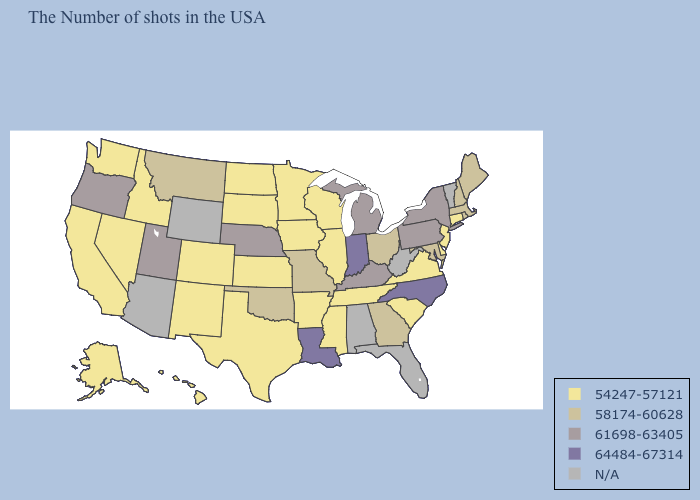What is the lowest value in the Northeast?
Short answer required. 54247-57121. What is the value of Massachusetts?
Keep it brief. 58174-60628. What is the highest value in the South ?
Be succinct. 64484-67314. Which states hav the highest value in the Northeast?
Be succinct. New York, Pennsylvania. What is the value of West Virginia?
Answer briefly. N/A. What is the highest value in the Northeast ?
Give a very brief answer. 61698-63405. What is the value of Montana?
Be succinct. 58174-60628. Which states have the lowest value in the USA?
Answer briefly. Connecticut, New Jersey, Delaware, Virginia, South Carolina, Tennessee, Wisconsin, Illinois, Mississippi, Arkansas, Minnesota, Iowa, Kansas, Texas, South Dakota, North Dakota, Colorado, New Mexico, Idaho, Nevada, California, Washington, Alaska, Hawaii. Does the map have missing data?
Keep it brief. Yes. Does the first symbol in the legend represent the smallest category?
Write a very short answer. Yes. What is the lowest value in the MidWest?
Quick response, please. 54247-57121. Name the states that have a value in the range 64484-67314?
Be succinct. North Carolina, Indiana, Louisiana. What is the value of Louisiana?
Keep it brief. 64484-67314. 